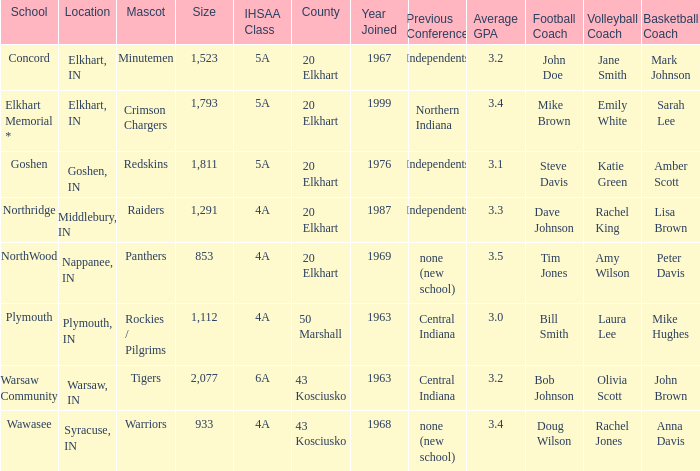What is the IHSAA class for the team located in Middlebury, IN? 4A. 